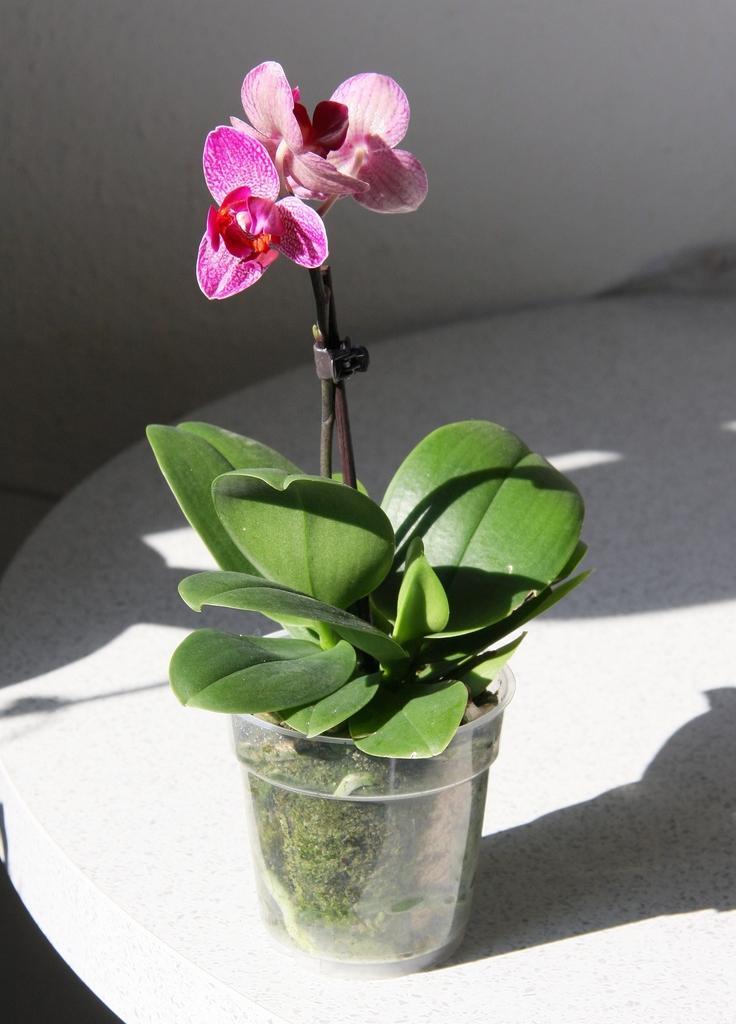Could you give a brief overview of what you see in this image? In the foreground of this image, there is a flower pot on the white color surface. Behind it, there is a white wall. 